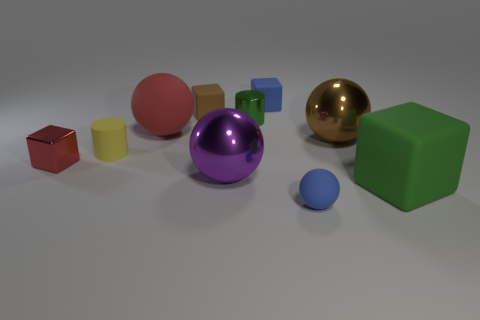Subtract 2 cubes. How many cubes are left? 2 Subtract all small cubes. How many cubes are left? 1 Subtract all yellow balls. Subtract all gray cylinders. How many balls are left? 4 Subtract all balls. How many objects are left? 6 Subtract 0 gray blocks. How many objects are left? 10 Subtract all large brown metallic things. Subtract all brown metallic spheres. How many objects are left? 8 Add 5 tiny brown matte blocks. How many tiny brown matte blocks are left? 6 Add 4 yellow things. How many yellow things exist? 5 